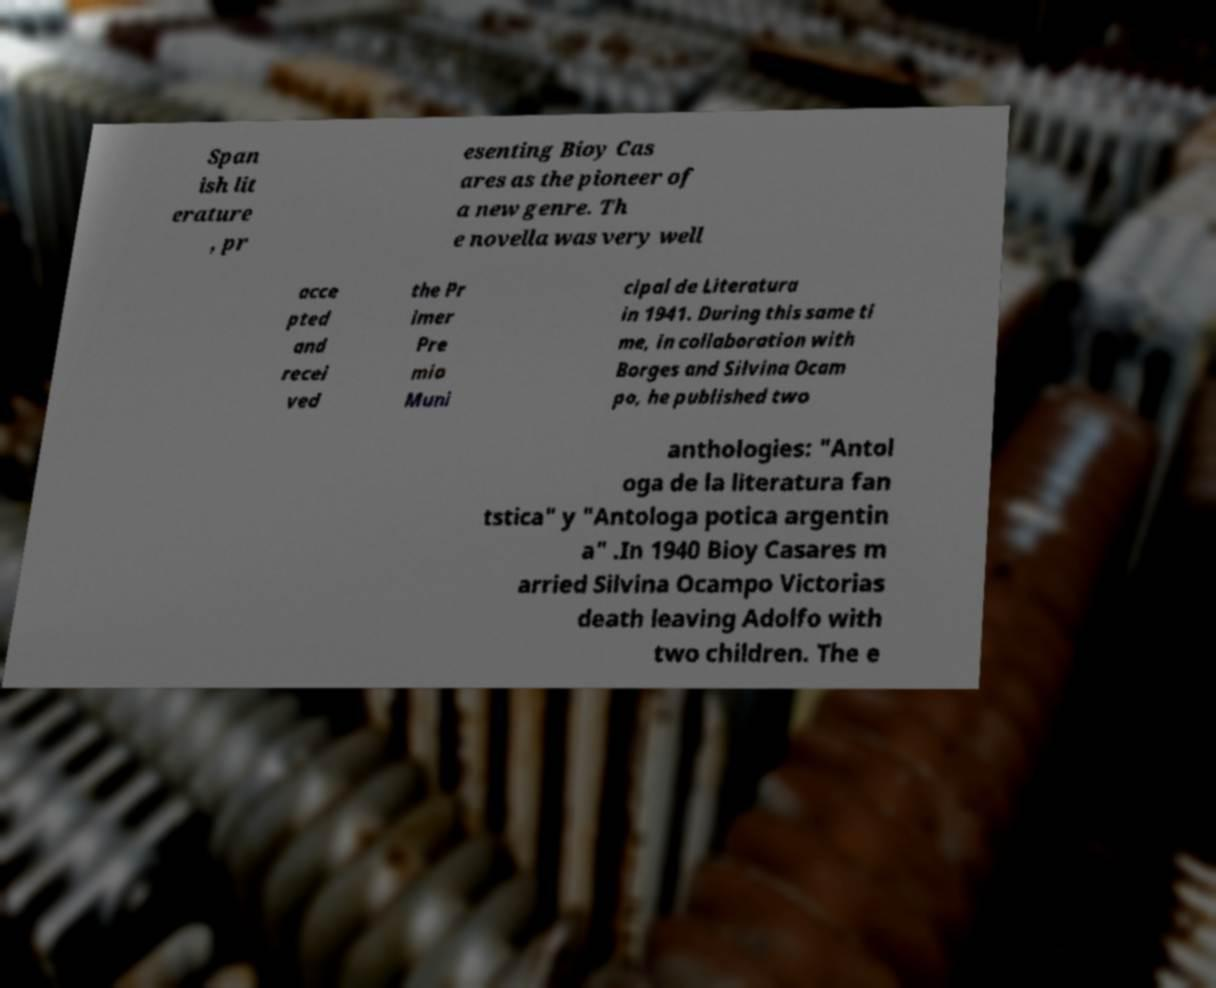For documentation purposes, I need the text within this image transcribed. Could you provide that? Span ish lit erature , pr esenting Bioy Cas ares as the pioneer of a new genre. Th e novella was very well acce pted and recei ved the Pr imer Pre mio Muni cipal de Literatura in 1941. During this same ti me, in collaboration with Borges and Silvina Ocam po, he published two anthologies: "Antol oga de la literatura fan tstica" y "Antologa potica argentin a" .In 1940 Bioy Casares m arried Silvina Ocampo Victorias death leaving Adolfo with two children. The e 